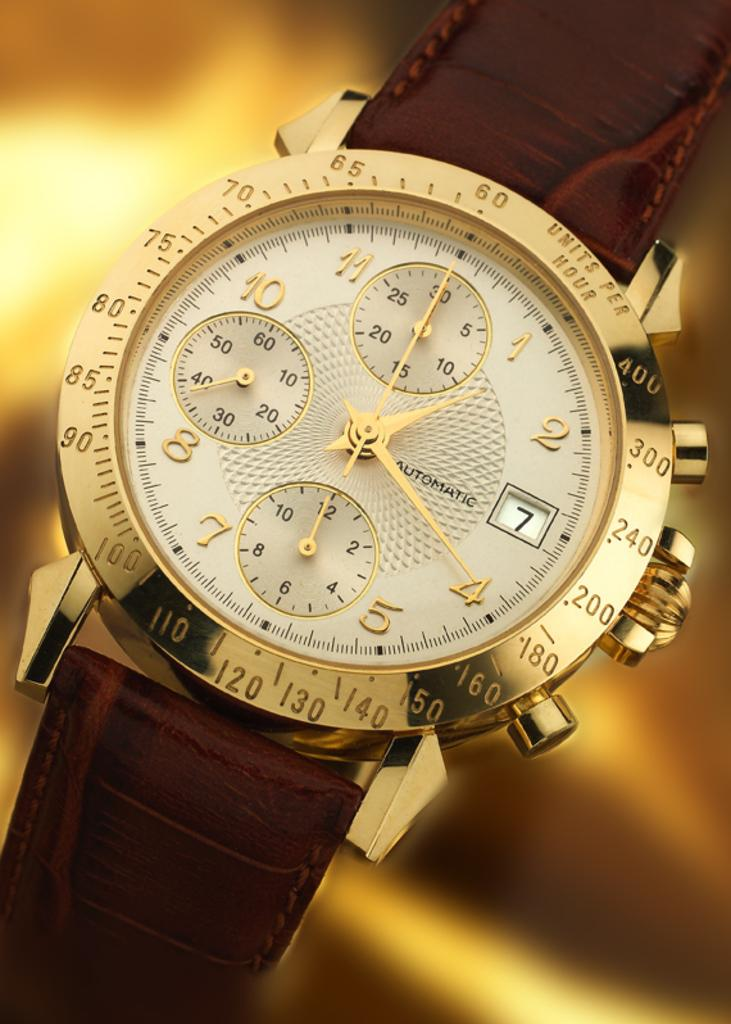<image>
Give a short and clear explanation of the subsequent image. a close up of a watch reading Automatic is gold and has a leather band 